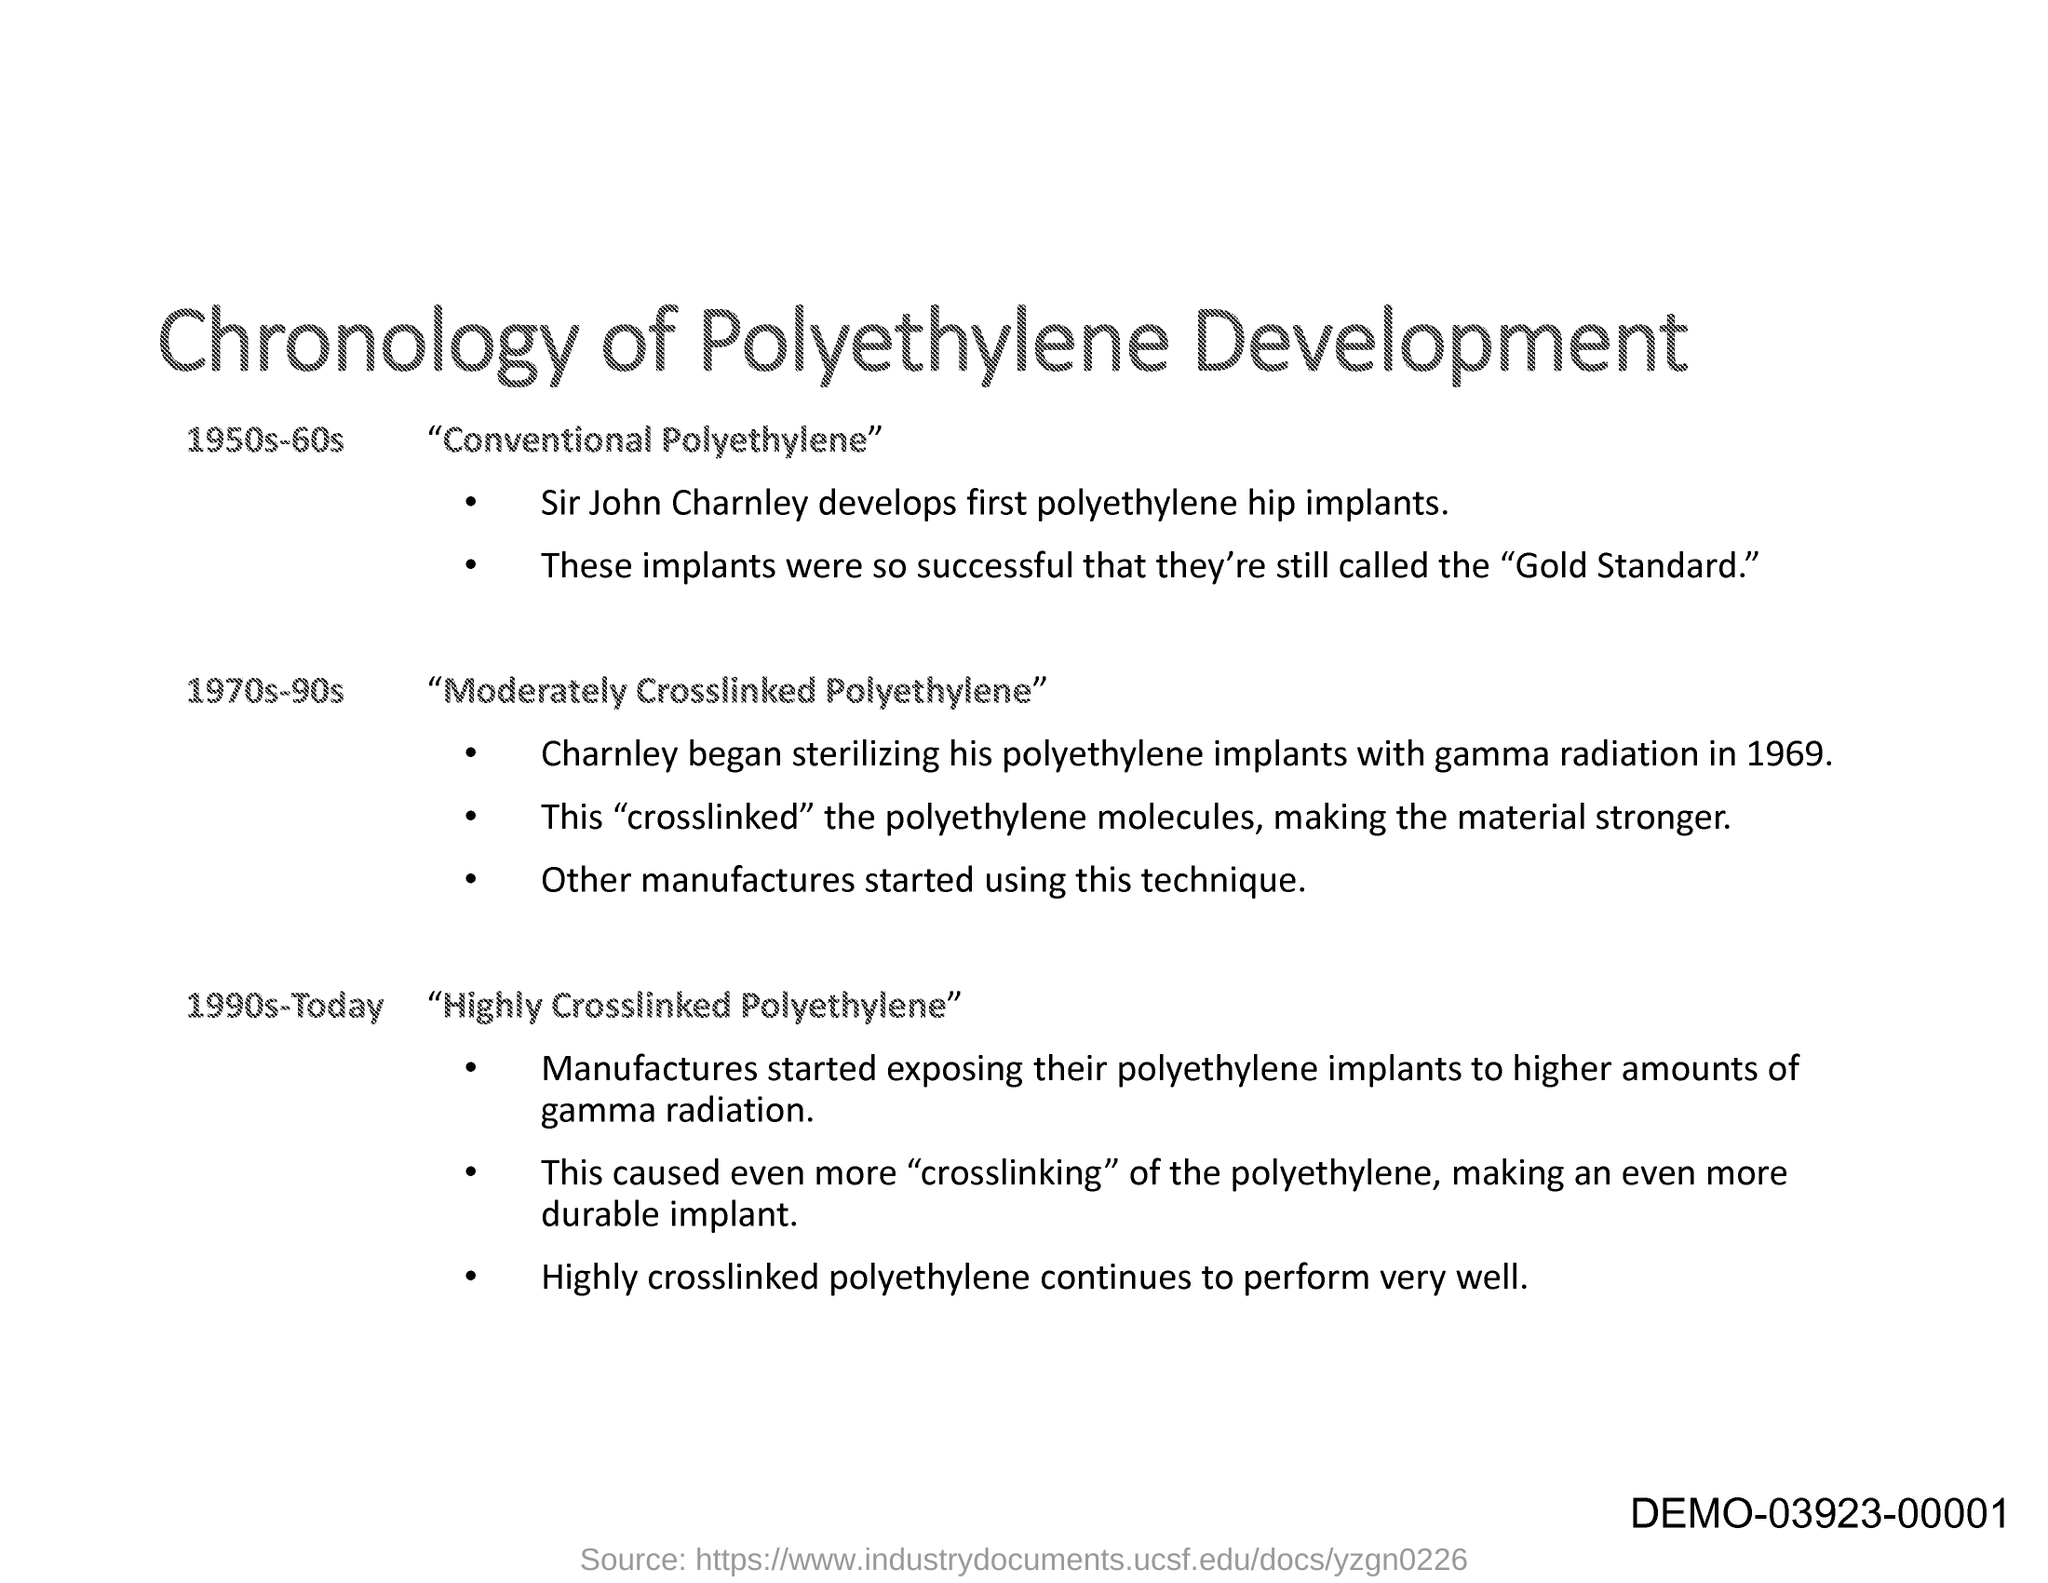What is the title of this document?
Offer a terse response. Chronology of Polyethylene Development. 